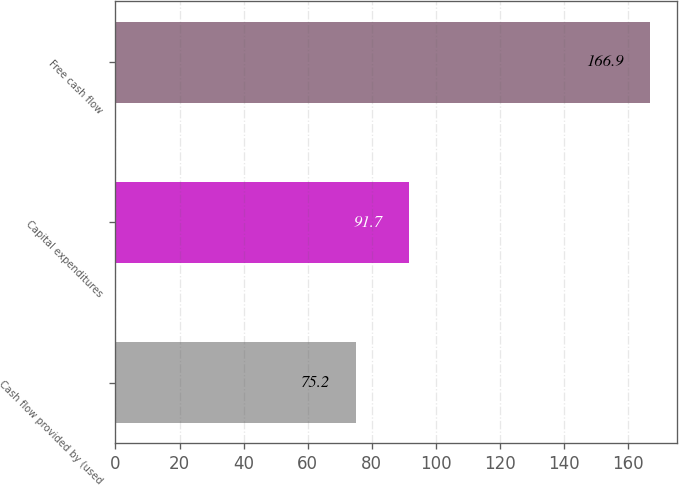<chart> <loc_0><loc_0><loc_500><loc_500><bar_chart><fcel>Cash flow provided by (used<fcel>Capital expenditures<fcel>Free cash flow<nl><fcel>75.2<fcel>91.7<fcel>166.9<nl></chart> 